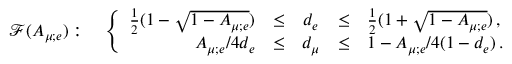<formula> <loc_0><loc_0><loc_500><loc_500>\mathcal { F } ( A _ { \mu ; e } ) \colon \quad \left \{ \begin{array} { r c c c l } { { \frac { 1 } { 2 } ( 1 - \sqrt { 1 - A _ { \mu ; e } } ) } } & { \leq } & { { d _ { e } } } & { \leq } & { { \frac { 1 } { 2 } ( 1 + \sqrt { 1 - A _ { \mu ; e } } ) \, , } } \\ { { A _ { \mu ; e } / 4 d _ { e } } } & { \leq } & { { d _ { \mu } } } & { \leq } & { { 1 - A _ { \mu ; e } / 4 ( 1 - d _ { e } ) \, . } } \end{array}</formula> 